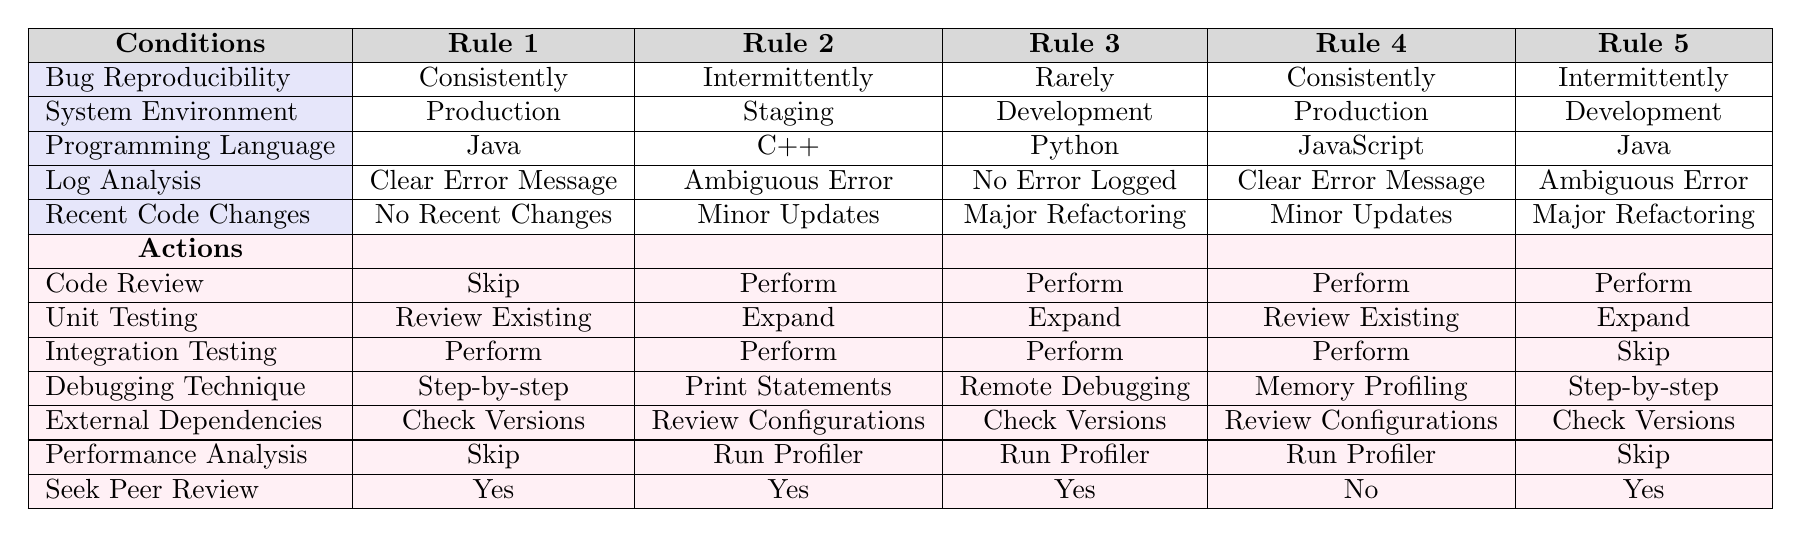What is the debugging technique suggested for Rule 2? In Rule 2, referring to the table, the debugging technique suggested is "Print Statements." This can be found in the respective row under the actions for Rule 2.
Answer: Print Statements Which rule suggests performing integration testing when the bug is consistently reproducible in a production environment? Looking at the table, Rule 1 suggests performing integration testing when the bug is consistently reproducible in a production setting, as indicated in the actions column for Rule 1.
Answer: Rule 1 Are there more rules that suggest seeking peer review? The table shows that Rules 1, 2, 3, and 5 all suggest seeking peer review (Yes), while Rule 4 does not (No). Therefore, the answer is yes, there are more rules that suggest this action.
Answer: Yes How many rules recommend unit testing to be expanded? By examining the table, we see that Rules 2, 3, and 5 recommend expanding unit testing. Counting these, we find three rules suggest expanding unit testing.
Answer: 3 If a bug is reported with no recent changes, clear error messages, and is consistently reproducible in a production environment, what actions are suggested? For the conditions described (no recent changes, clear error messages, consistently reproducible, production environment), we refer to Rule 1. The suggested actions are to skip code review, review existing unit tests, perform integration testing, use step-by-step debugging, check versions of external dependencies, skip performance analysis, and seek peer review. Consequently, the actions listed clearly address the reported conditions.
Answer: Skip, Review Existing, Perform, Step-by-step, Check Versions, Skip, Yes What action is proposed for integration testing in the scenario of an intermittent bug in a staging environment? In Rule 2, which corresponds to an intermittent bug in a staging environment, the proposed action for integration testing is to perform it. This is directly indicated in the actions for Rule 2 of the table.
Answer: Perform Which programming language was associated with the rule that includes conducting unit testing as a review of existing tests? Referring to the table, Rule 1 is associated with the programming language Java and states to review existing unit tests, which is found in the actions column under Rule 1.
Answer: Java Is there any rule where "Skip" is recommended for performance analysis? By reviewing the table, it can be seen that "Skip" for performance analysis is recommended in Rule 1 and Rule 5. Thus, the answer is yes; there are multiple instances where this action is prescribed.
Answer: Yes For a bug that occurs rarely in a development environment with no error logged and recent major refactoring, what actions are recommended? Referring to Rule 3, these specific conditions match exactly, and the recommended actions include performing code review, expanding unit testing, performing integration testing, using remote debugging, checking versions of external dependencies, running the profiler for performance analysis, and seeking peer review. All these actions are neatly listed in the actions column under Rule 3, outlining how to proceed in this situation.
Answer: Perform, Expand, Perform, Remote Debugging, Check Versions, Run Profiler, Yes 